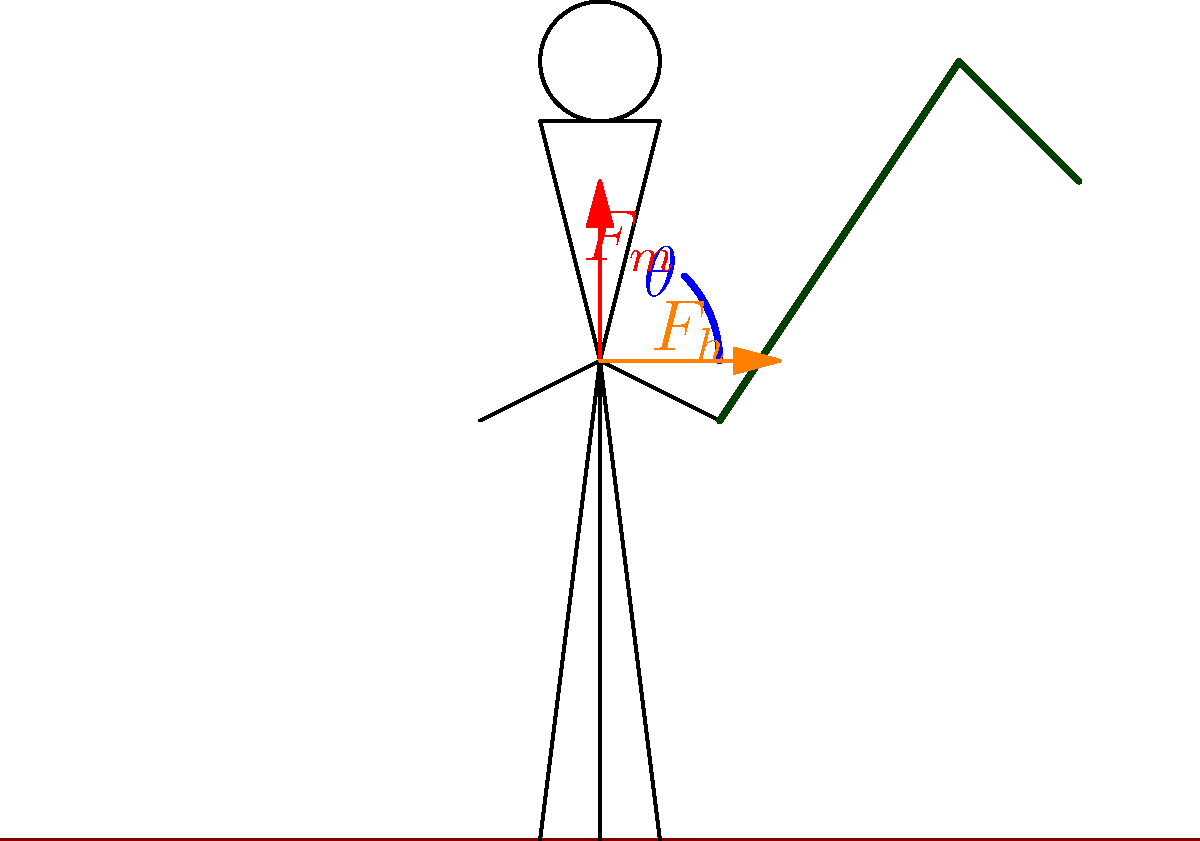When using a traditional Nigerian hoe for farming, the muscular force ($F_m$) applied by the farmer forms an angle $\theta$ with the horizontal. If the magnitude of $F_m$ is 200 N and $\theta$ is 45°, what is the magnitude of the horizontal component of force ($F_h$) applied to the hoe handle? To solve this problem, we need to follow these steps:

1. Understand the force diagram:
   - $F_m$ represents the total muscular force applied by the farmer
   - $\theta$ is the angle between $F_m$ and the horizontal
   - $F_h$ is the horizontal component of $F_m$

2. Recall the trigonometric relationship for finding the adjacent side in a right triangle:
   $\cos \theta = \frac{\text{adjacent}}{\text{hypotenuse}} = \frac{F_h}{F_m}$

3. Rearrange the equation to solve for $F_h$:
   $F_h = F_m \cos \theta$

4. Substitute the given values:
   $F_m = 200 \text{ N}$
   $\theta = 45°$

5. Calculate $F_h$:
   $F_h = 200 \text{ N} \times \cos 45°$
   $F_h = 200 \text{ N} \times \frac{\sqrt{2}}{2}$
   $F_h = 100\sqrt{2} \text{ N}$

6. Simplify the result:
   $F_h \approx 141.4 \text{ N}$

Therefore, the magnitude of the horizontal component of force ($F_h$) applied to the hoe handle is approximately 141.4 N.
Answer: 141.4 N 